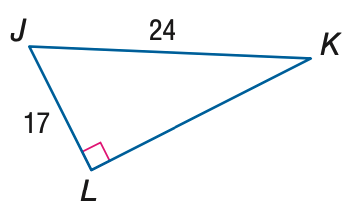Question: Use a calculator to find the measure of \angle J to the nearest degree.
Choices:
A. 35
B. 45
C. 55
D. 65
Answer with the letter. Answer: B 